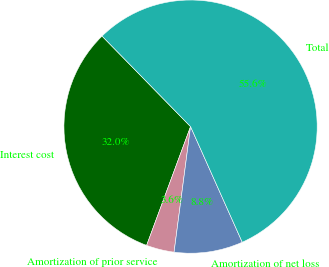Convert chart to OTSL. <chart><loc_0><loc_0><loc_500><loc_500><pie_chart><fcel>Interest cost<fcel>Amortization of prior service<fcel>Amortization of net loss<fcel>Total<nl><fcel>32.04%<fcel>3.56%<fcel>8.77%<fcel>55.63%<nl></chart> 